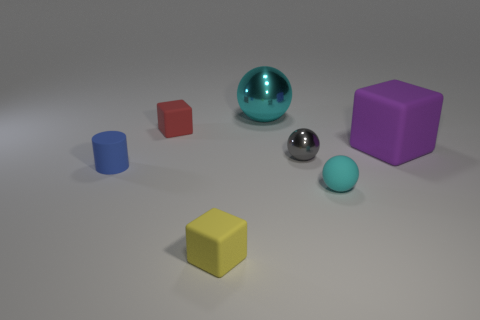There is another small object that is the same shape as the gray object; what material is it?
Provide a succinct answer. Rubber. What number of spheres are large objects or yellow matte things?
Keep it short and to the point. 1. Do the matte block that is to the right of the yellow block and the cyan object to the left of the small gray metallic ball have the same size?
Your answer should be very brief. Yes. There is a tiny ball that is behind the small cylinder that is left of the purple object; what is its material?
Give a very brief answer. Metal. Is the number of small spheres in front of the yellow rubber thing less than the number of red rubber objects?
Provide a succinct answer. Yes. The thing that is made of the same material as the large cyan ball is what shape?
Offer a terse response. Sphere. What number of other things are the same shape as the blue thing?
Your answer should be very brief. 0. What number of green objects are matte balls or big balls?
Your response must be concise. 0. Is the shape of the cyan matte thing the same as the small shiny object?
Provide a short and direct response. Yes. Is there a tiny yellow cube that is in front of the small red matte cube behind the tiny cyan object?
Make the answer very short. Yes. 